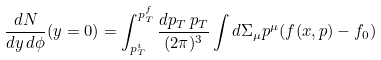<formula> <loc_0><loc_0><loc_500><loc_500>\frac { d N } { d y \, d \phi } ( y = 0 ) = \int _ { p ^ { i } _ { T } } ^ { p ^ { f } _ { T } } \frac { d p _ { T } \, p _ { T } } { ( 2 \pi ) ^ { 3 } } \int d \Sigma _ { \mu } p ^ { \mu } ( f ( x , p ) - f _ { 0 } )</formula> 